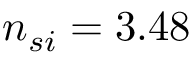<formula> <loc_0><loc_0><loc_500><loc_500>n _ { s i } = 3 . 4 8</formula> 